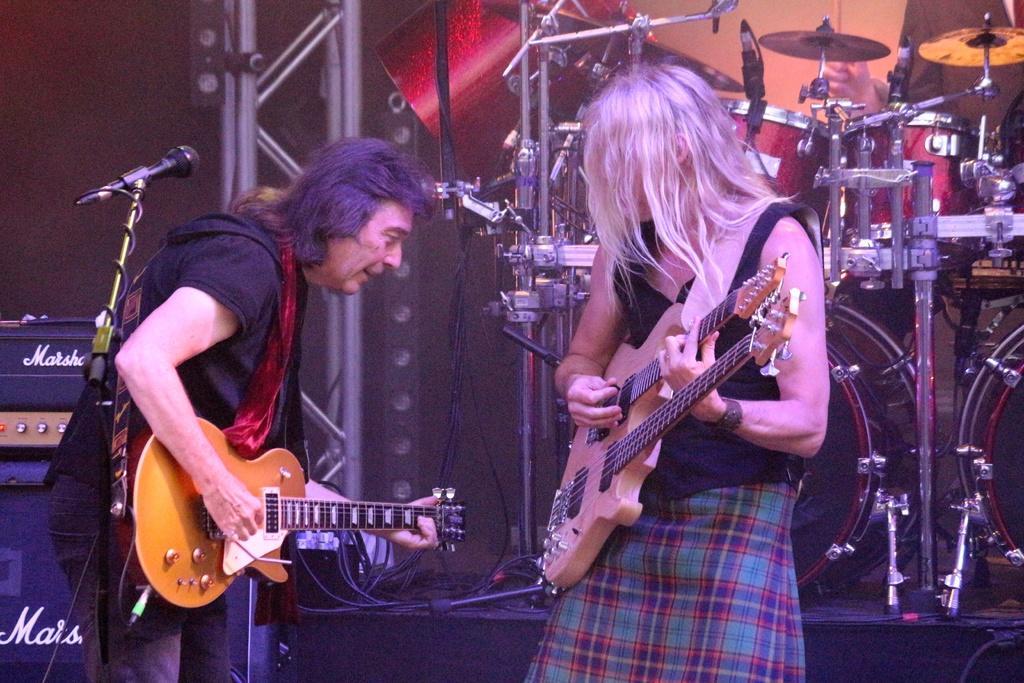How would you summarize this image in a sentence or two? In this image there are two persons playing a musical instruments. 